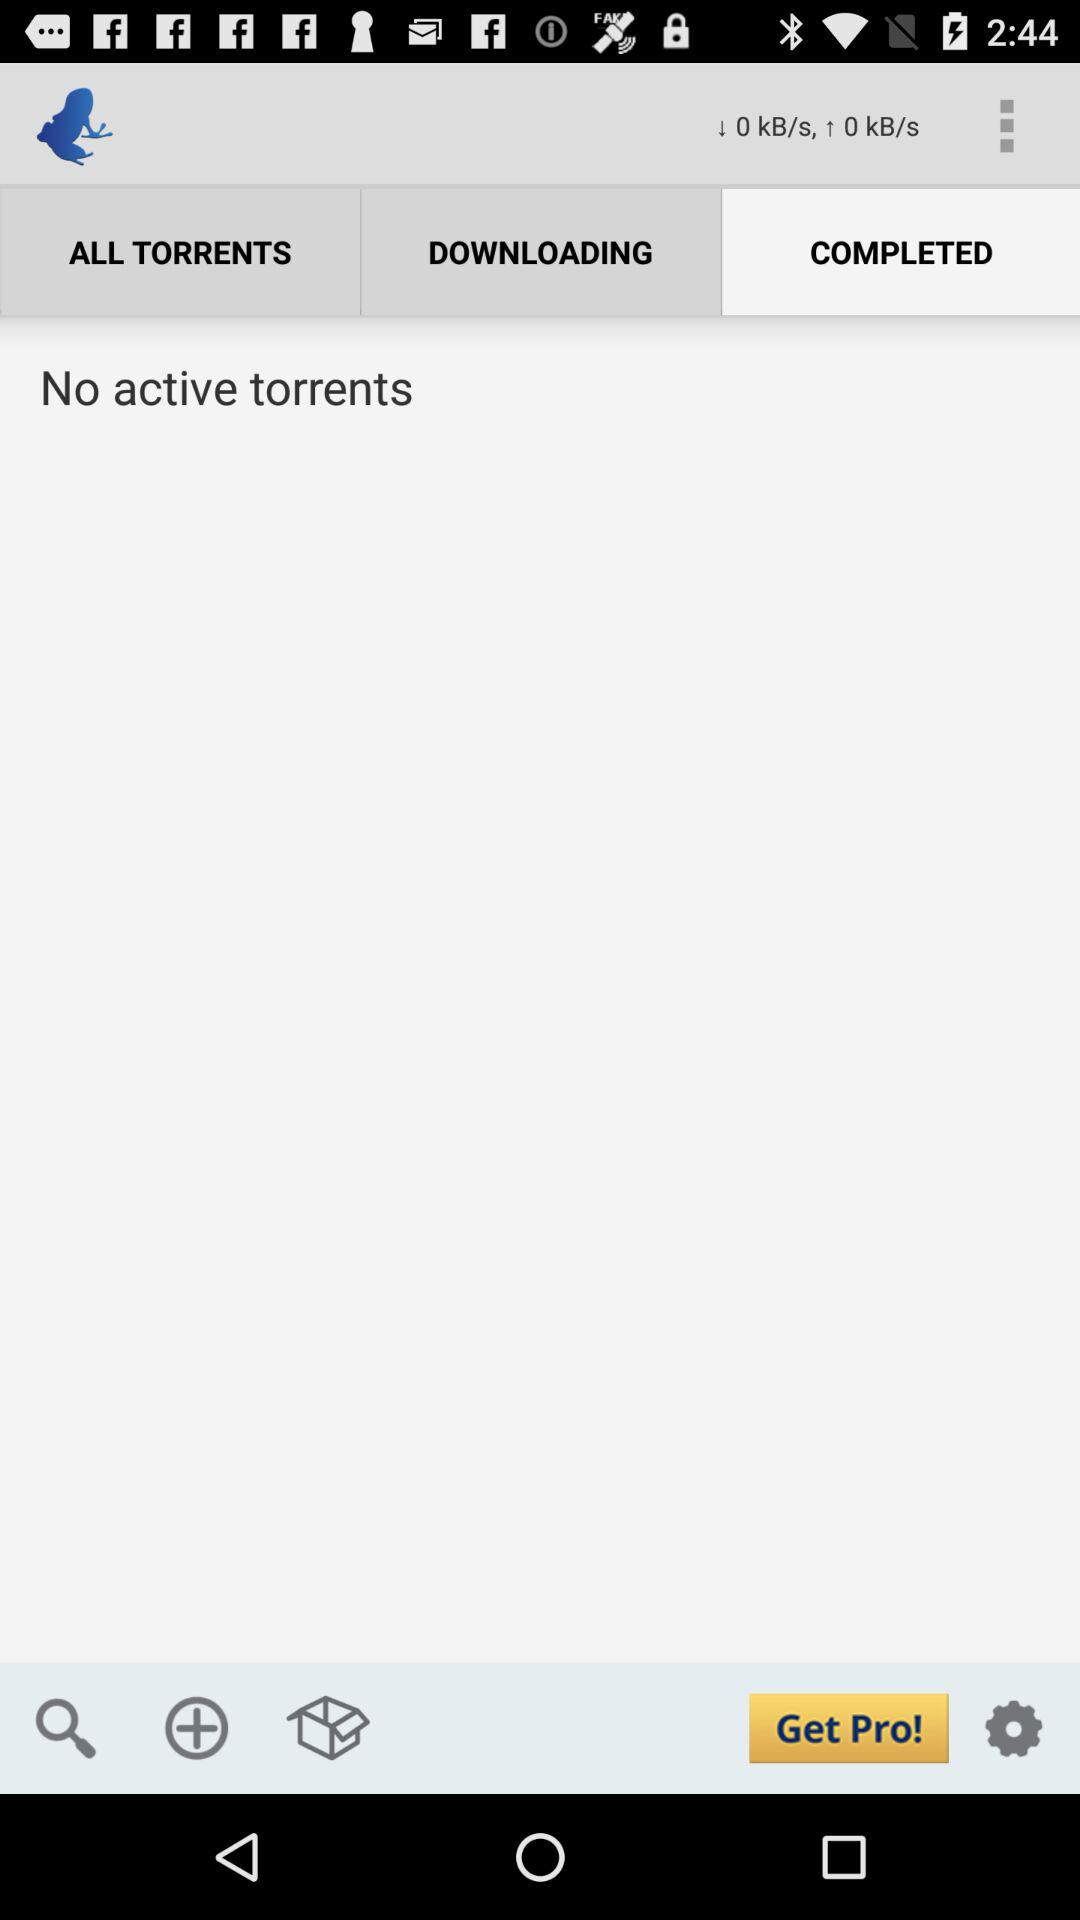What is the uploading speed? The uploading speed is 0 kB/s. 